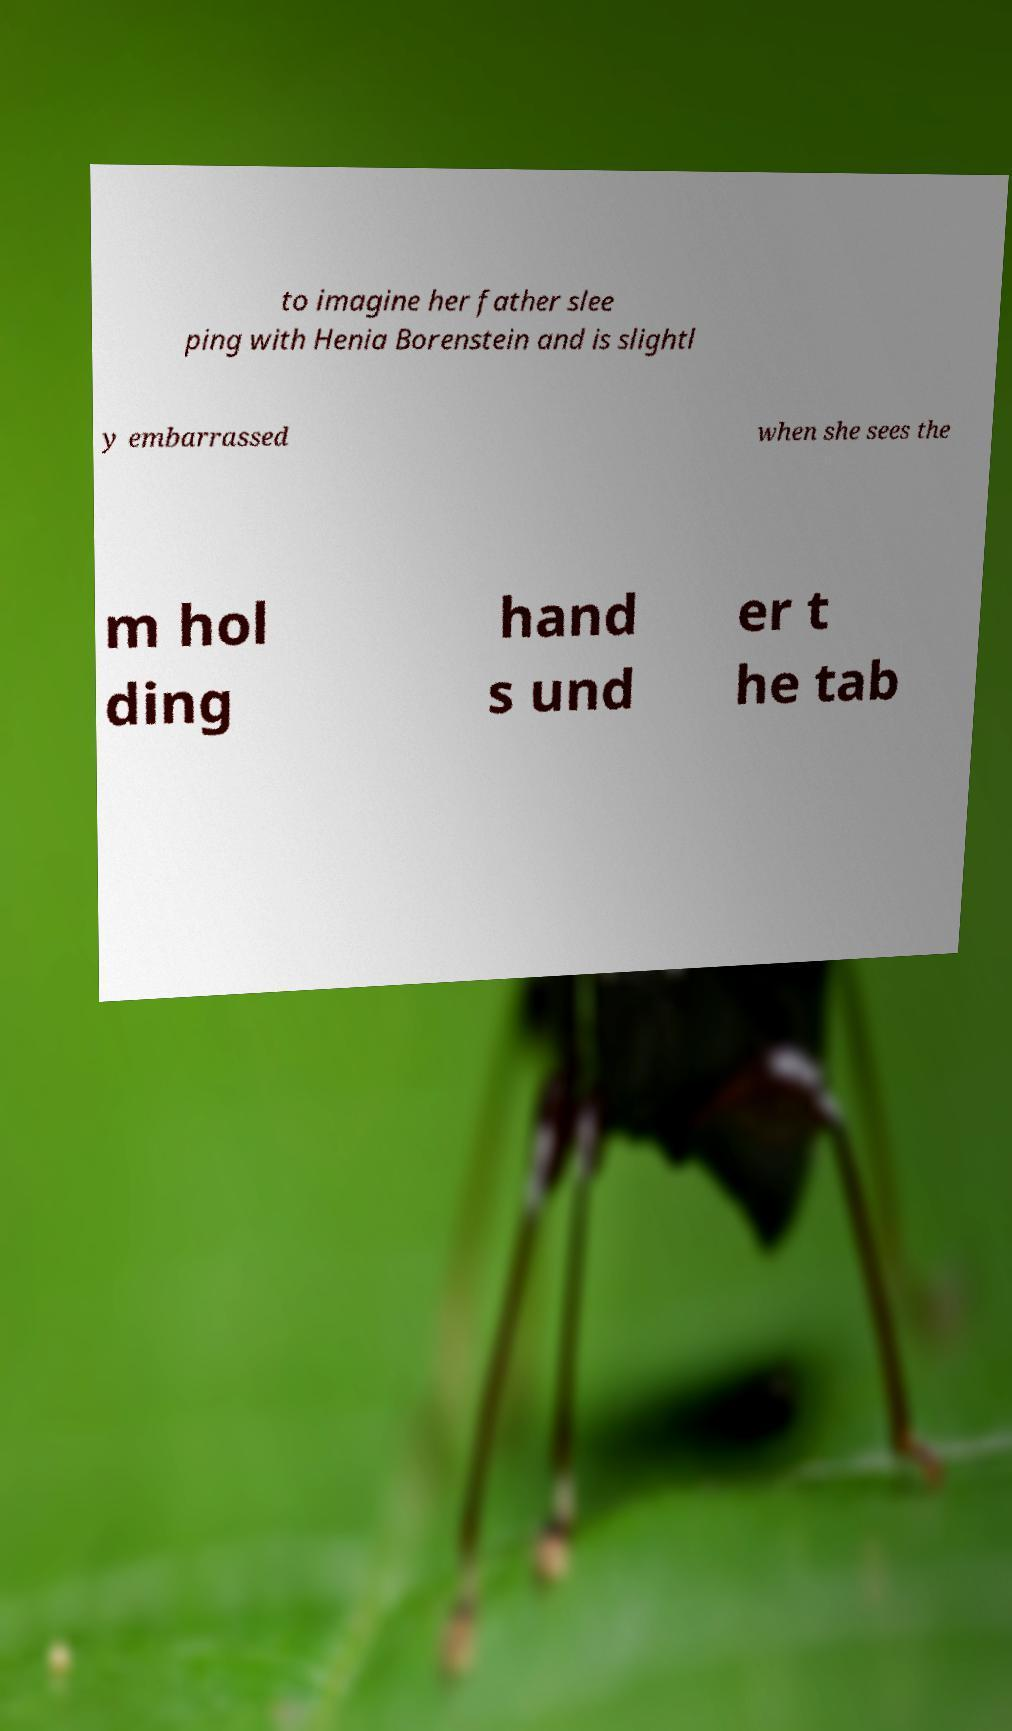Please read and relay the text visible in this image. What does it say? to imagine her father slee ping with Henia Borenstein and is slightl y embarrassed when she sees the m hol ding hand s und er t he tab 